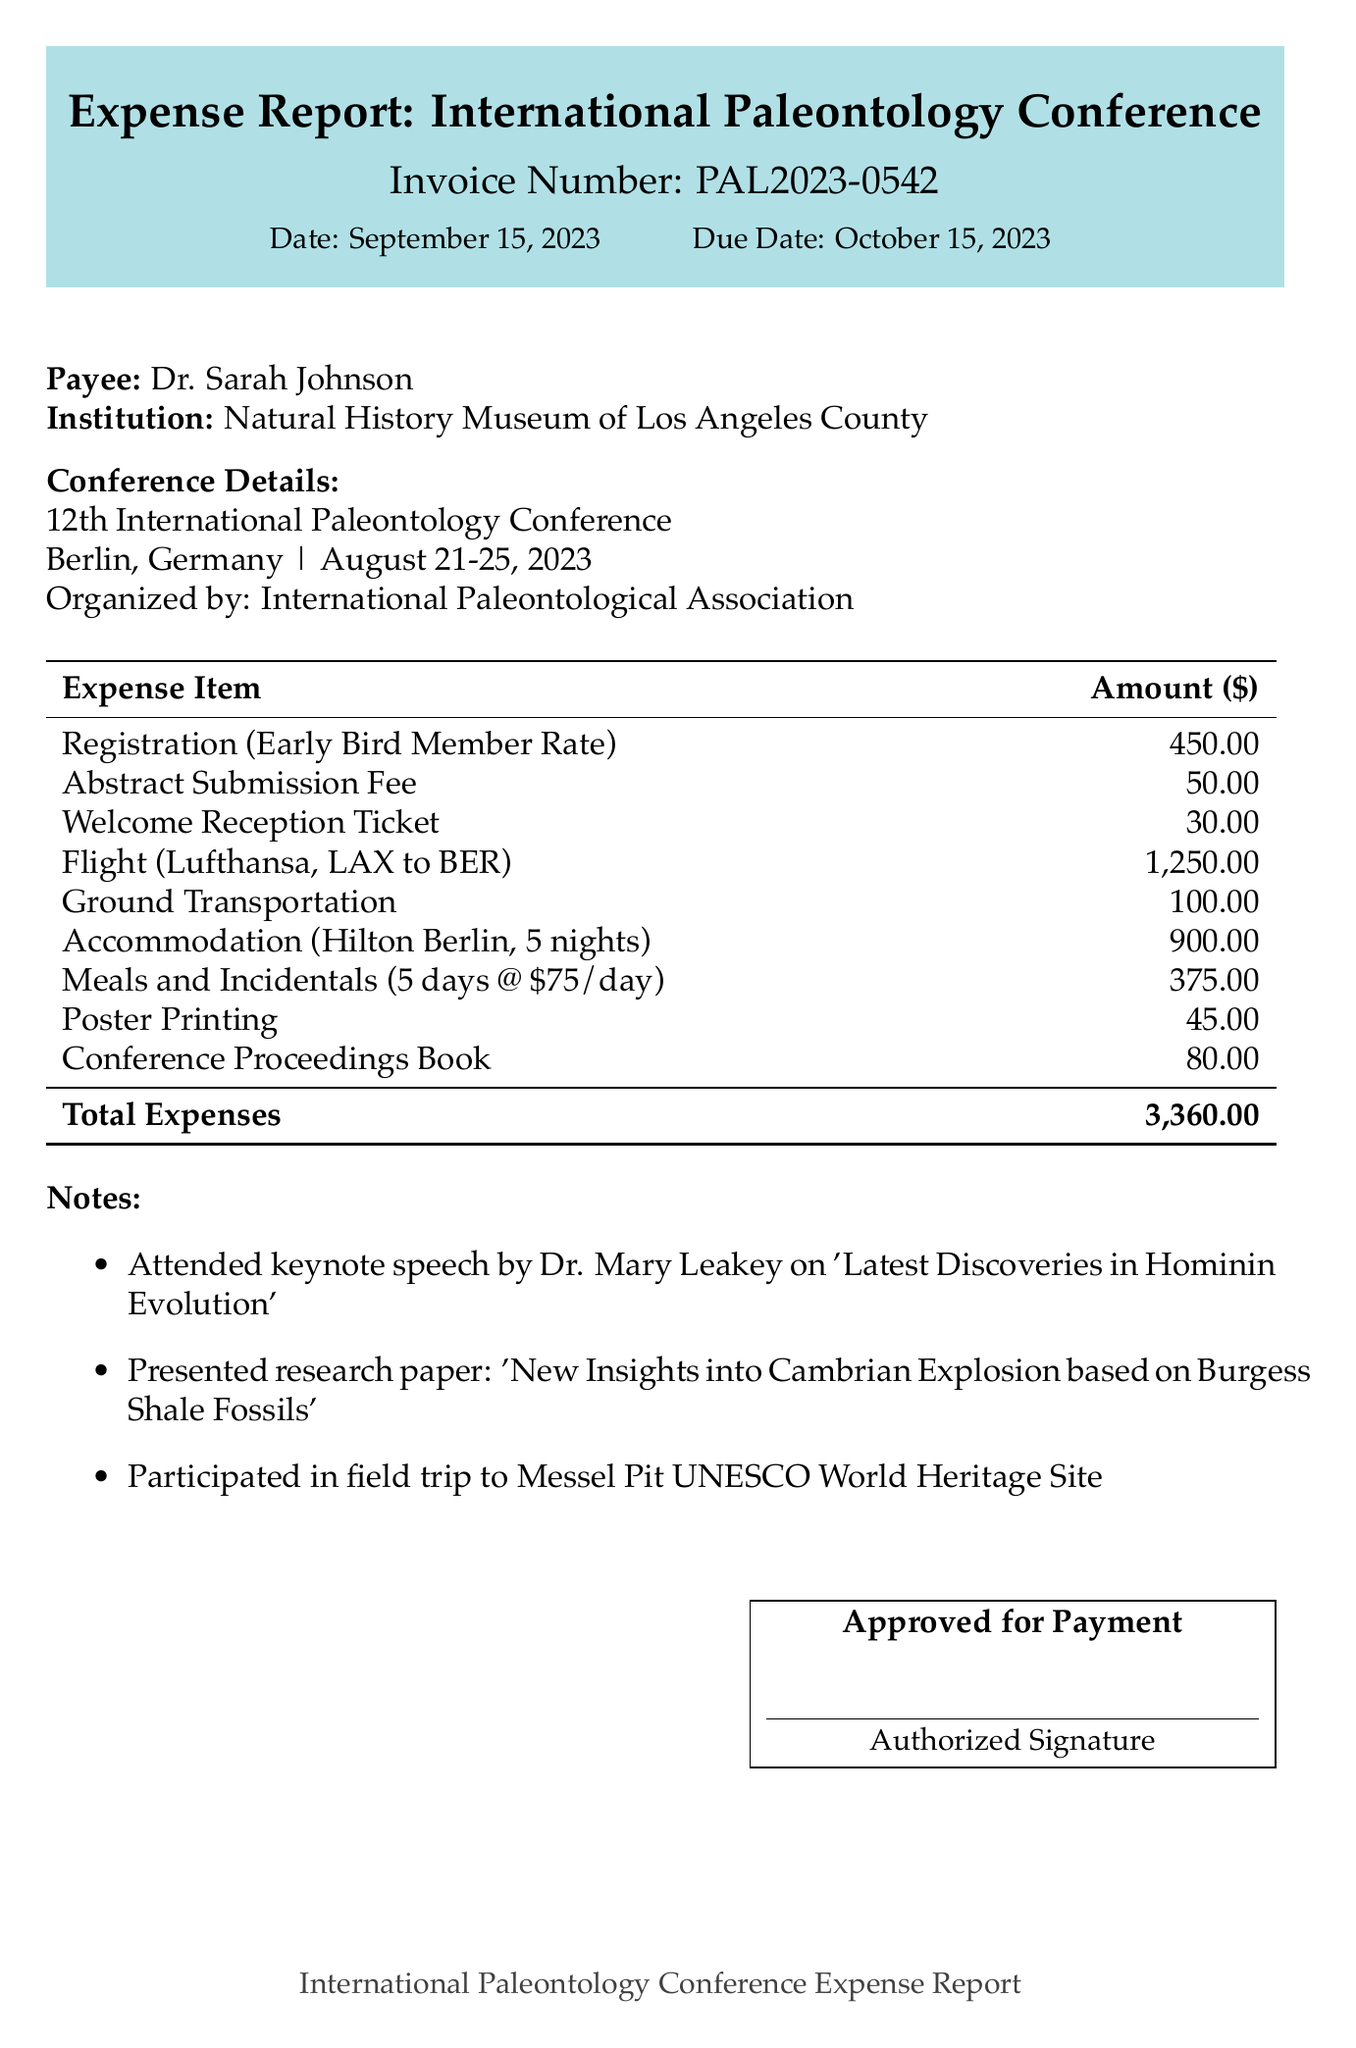What is the invoice number? The invoice number is unique and identifies the invoice in the document, which is listed as PAL2023-0542.
Answer: PAL2023-0542 What is the total accommodation cost? The total accommodation cost is calculated based on the rate per night and the number of nights stayed, which is 180.00 per night for 5 nights totaling 900.00.
Answer: 900.00 Who organized the conference? The organizer's name is mentioned in the conference details, which states it is organized by the International Paleontological Association.
Answer: International Paleontological Association What is the per diem rate? The per diem rate is provided in the meals and incidentals section, which specifies an allowance for daily expenses.
Answer: 75.00 How many nights did Dr. Sarah Johnson stay at the hotel? The duration of the stay is explicitly stated as 5 nights in the accommodation details of the document.
Answer: 5 What was the cost of the flight? The flight cost is detailed under travel expenses, highlighting the total charge for the round trip from Los Angeles to Berlin.
Answer: 1250.00 What was the total expense for ground transportation? The total cost for ground transportation is the sum of airport transfers and public transport, resulting in an aggregate value found in the expenses section.
Answer: 100.00 What date is the invoice due? The due date is clearly specified in the invoice details and indicates when payment must be made.
Answer: October 15, 2023 What activity did Dr. Sarah Johnson participate in at the conference? The activities noted include attendance, presentation of research, and participation in a field trip, highlighting her engagement in the conference events.
Answer: Keynote speech, presentation, field trip 